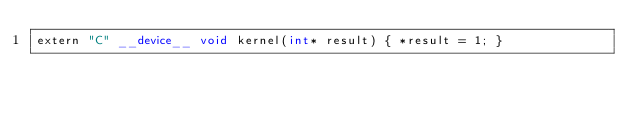Convert code to text. <code><loc_0><loc_0><loc_500><loc_500><_Cuda_>extern "C" __device__ void kernel(int* result) { *result = 1; }
</code> 